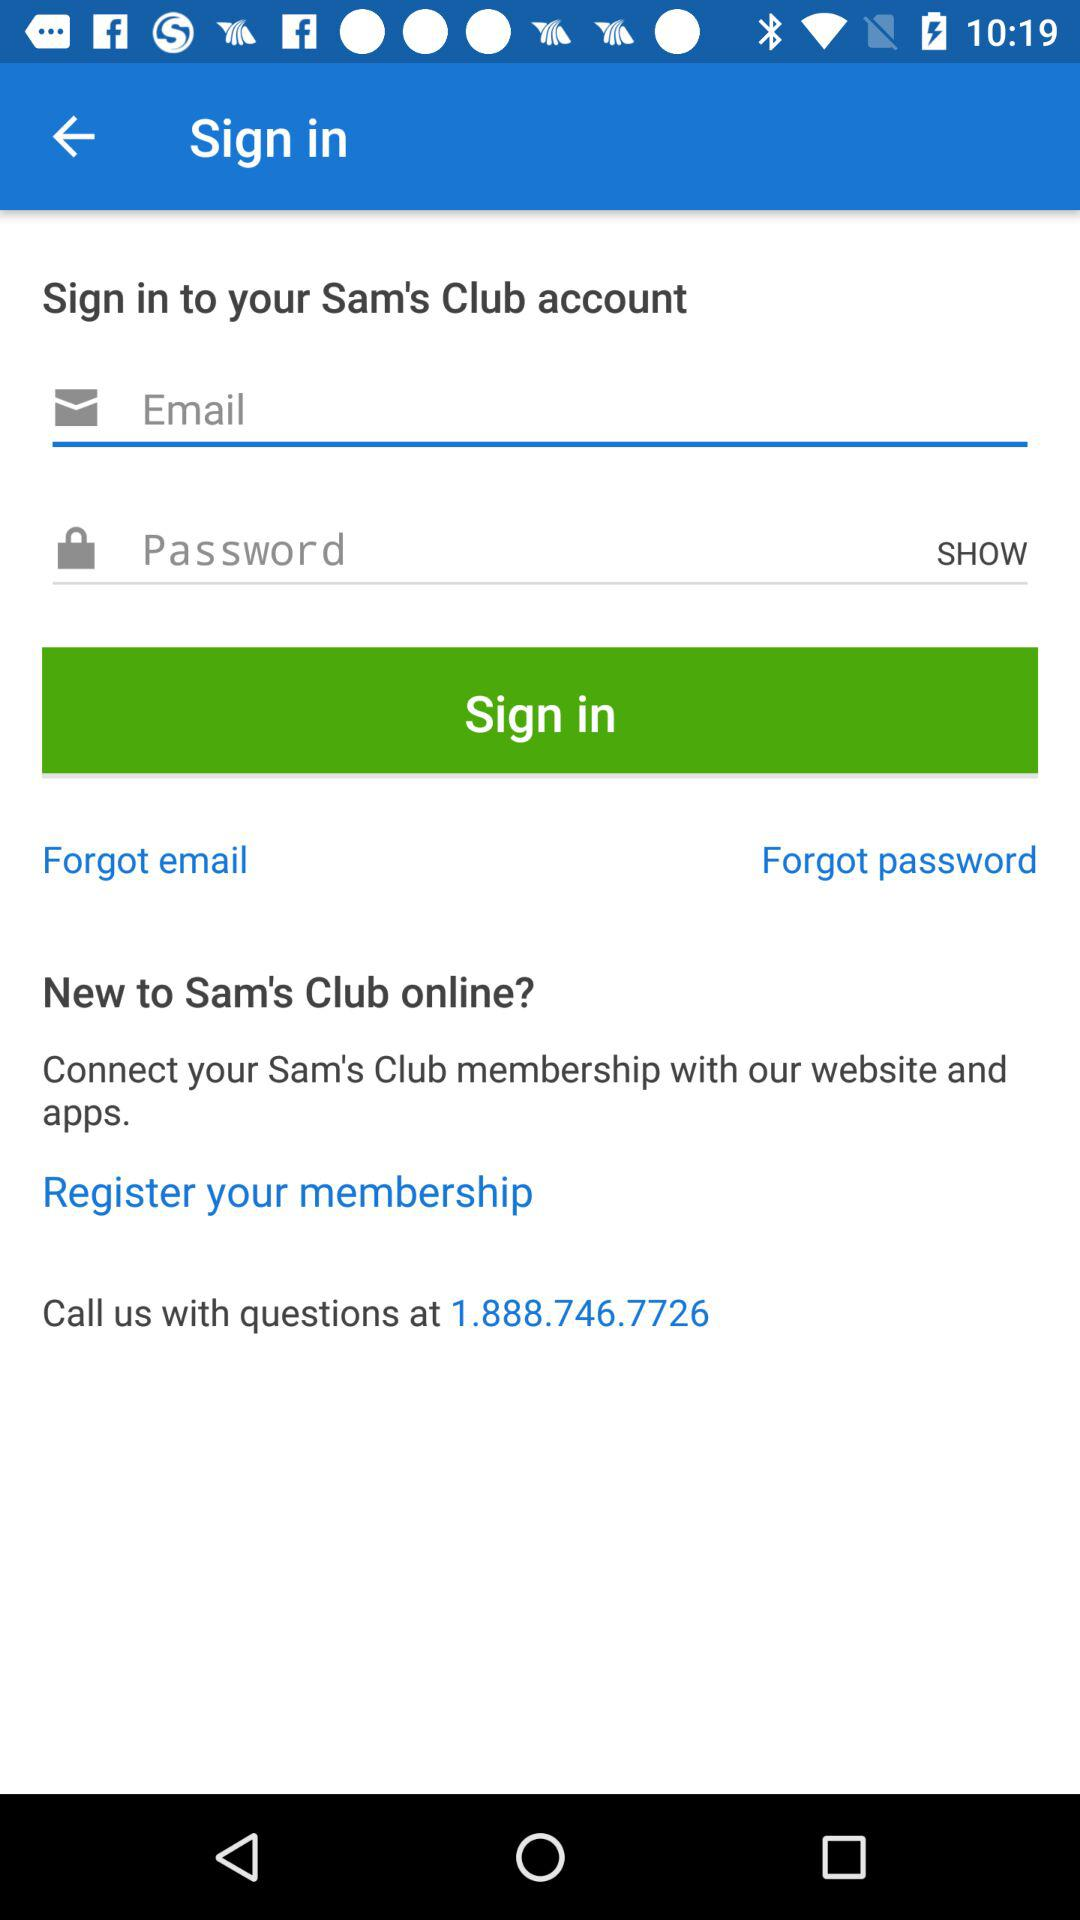Through what account can we sign in? You can sign in with "Sam's Club". 